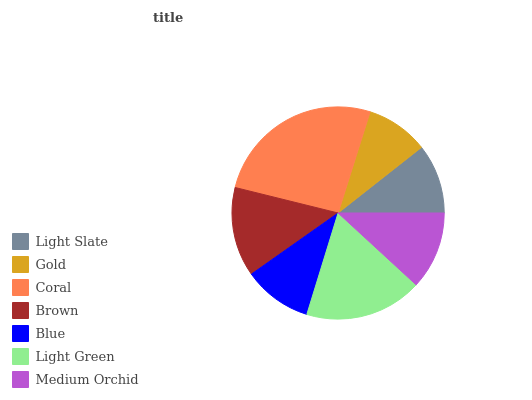Is Gold the minimum?
Answer yes or no. Yes. Is Coral the maximum?
Answer yes or no. Yes. Is Coral the minimum?
Answer yes or no. No. Is Gold the maximum?
Answer yes or no. No. Is Coral greater than Gold?
Answer yes or no. Yes. Is Gold less than Coral?
Answer yes or no. Yes. Is Gold greater than Coral?
Answer yes or no. No. Is Coral less than Gold?
Answer yes or no. No. Is Medium Orchid the high median?
Answer yes or no. Yes. Is Medium Orchid the low median?
Answer yes or no. Yes. Is Brown the high median?
Answer yes or no. No. Is Light Green the low median?
Answer yes or no. No. 